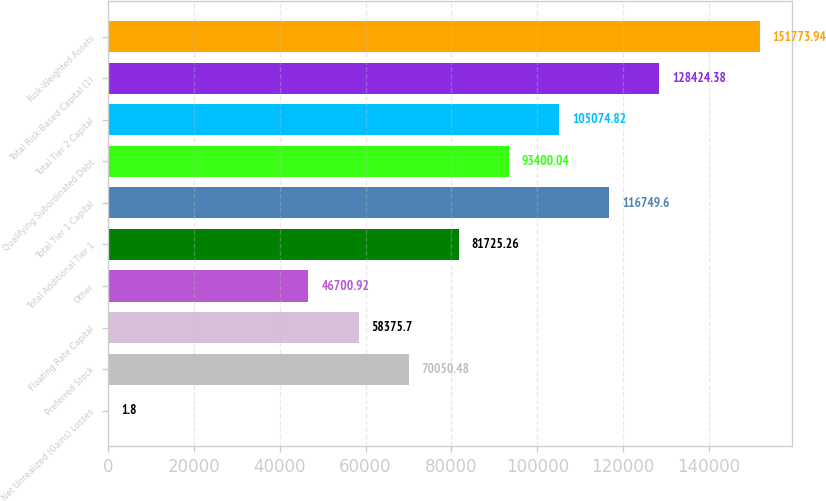Convert chart to OTSL. <chart><loc_0><loc_0><loc_500><loc_500><bar_chart><fcel>Net Unrealized (Gains) Losses<fcel>Preferred Stock<fcel>Floating Rate Capital<fcel>Other<fcel>Total Additional Tier 1<fcel>Total Tier 1 Capital<fcel>Qualifying Subordinated Debt<fcel>Total Tier 2 Capital<fcel>Total Risk-Based Capital (1)<fcel>Risk-Weighted Assets<nl><fcel>1.8<fcel>70050.5<fcel>58375.7<fcel>46700.9<fcel>81725.3<fcel>116750<fcel>93400<fcel>105075<fcel>128424<fcel>151774<nl></chart> 